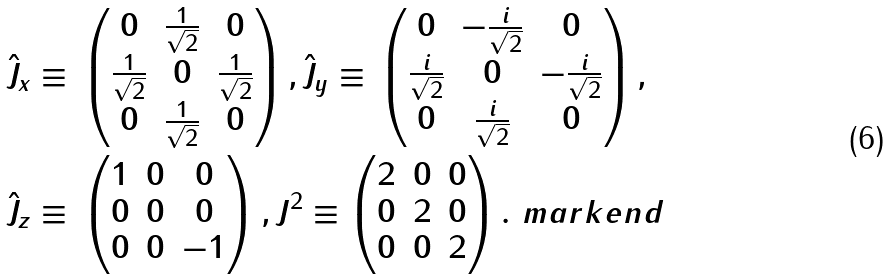Convert formula to latex. <formula><loc_0><loc_0><loc_500><loc_500>\hat { J } _ { x } & \equiv \, \begin{pmatrix} 0 & \frac { 1 } { \sqrt { 2 } } & 0 \\ \frac { 1 } { \sqrt { 2 } } & 0 & \frac { 1 } { \sqrt { 2 } } \\ 0 & \frac { 1 } { \sqrt { 2 } } & 0 \end{pmatrix} , \hat { J } _ { y } \equiv \, \begin{pmatrix} 0 & - \frac { i } { \sqrt { 2 } } & 0 \\ \frac { i } { \sqrt { 2 } } & 0 & - \frac { i } { \sqrt { 2 } } \\ 0 & \frac { i } { \sqrt { 2 } } & 0 \end{pmatrix} , \\ \hat { J } _ { z } & \equiv \, \begin{pmatrix} 1 & 0 & 0 \\ 0 & 0 & 0 \\ 0 & 0 & - 1 \end{pmatrix} , J ^ { 2 } \equiv \begin{pmatrix} 2 & 0 & 0 \\ 0 & 2 & 0 \\ 0 & 0 & 2 \end{pmatrix} . \ m a r k e n d</formula> 